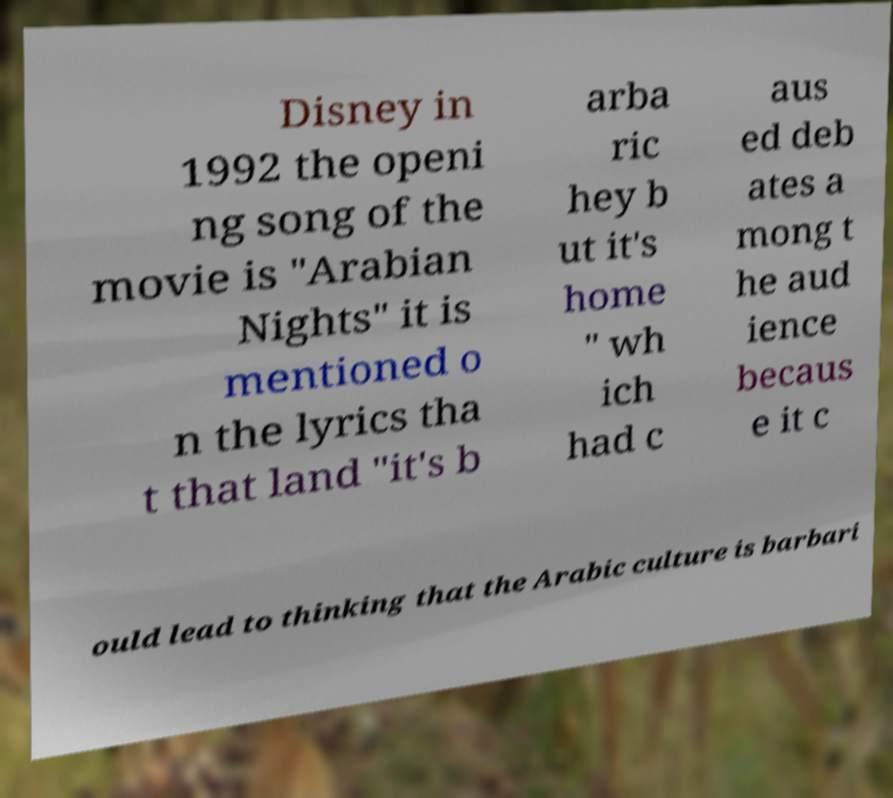Can you accurately transcribe the text from the provided image for me? Disney in 1992 the openi ng song of the movie is "Arabian Nights" it is mentioned o n the lyrics tha t that land "it's b arba ric hey b ut it's home " wh ich had c aus ed deb ates a mong t he aud ience becaus e it c ould lead to thinking that the Arabic culture is barbari 